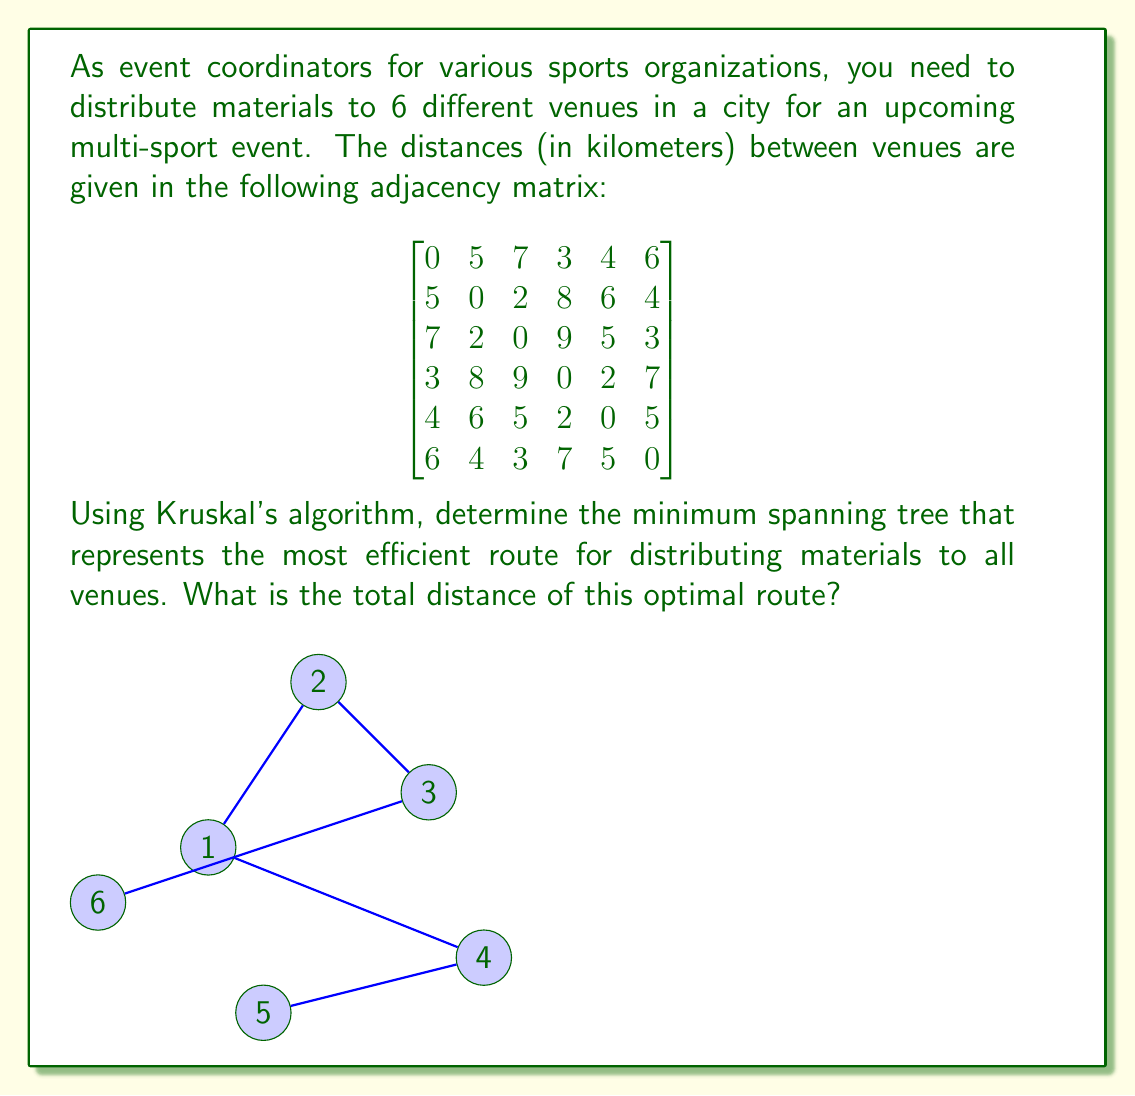Solve this math problem. To solve this problem, we'll use Kruskal's algorithm to find the minimum spanning tree (MST) of the graph represented by the given adjacency matrix. Here's the step-by-step process:

1. List all edges and their weights in ascending order:
   (2,3): 2, (3,4): 2, (1,4): 3, (1,5): 4, (2,6): 4, (3,5): 5, (1,2): 5, (4,5): 5, (1,6): 6, (2,5): 6, (3,6): 3, (1,3): 7, (4,6): 7, (2,4): 8, (3,4): 9

2. Initialize a disjoint set for each vertex.

3. Iterate through the sorted edges:
   a. (2,3): 2 - Add to MST
   b. (3,4): 2 - Add to MST
   c. (1,4): 3 - Add to MST
   d. (3,6): 3 - Add to MST
   e. (1,5): 4 - Add to MST

4. Stop as we have added 5 edges (n-1 edges for n vertices).

The resulting minimum spanning tree consists of the following edges:
(2,3), (3,4), (1,4), (3,6), (1,5)

To calculate the total distance of the optimal route, sum the weights of these edges:

$$ \text{Total distance} = 2 + 2 + 3 + 3 + 4 = 14 \text{ km} $$

The blue edges in the diagram represent the minimum spanning tree, which is the most efficient route for distributing materials to all venues.
Answer: The total distance of the optimal route is 14 km. 